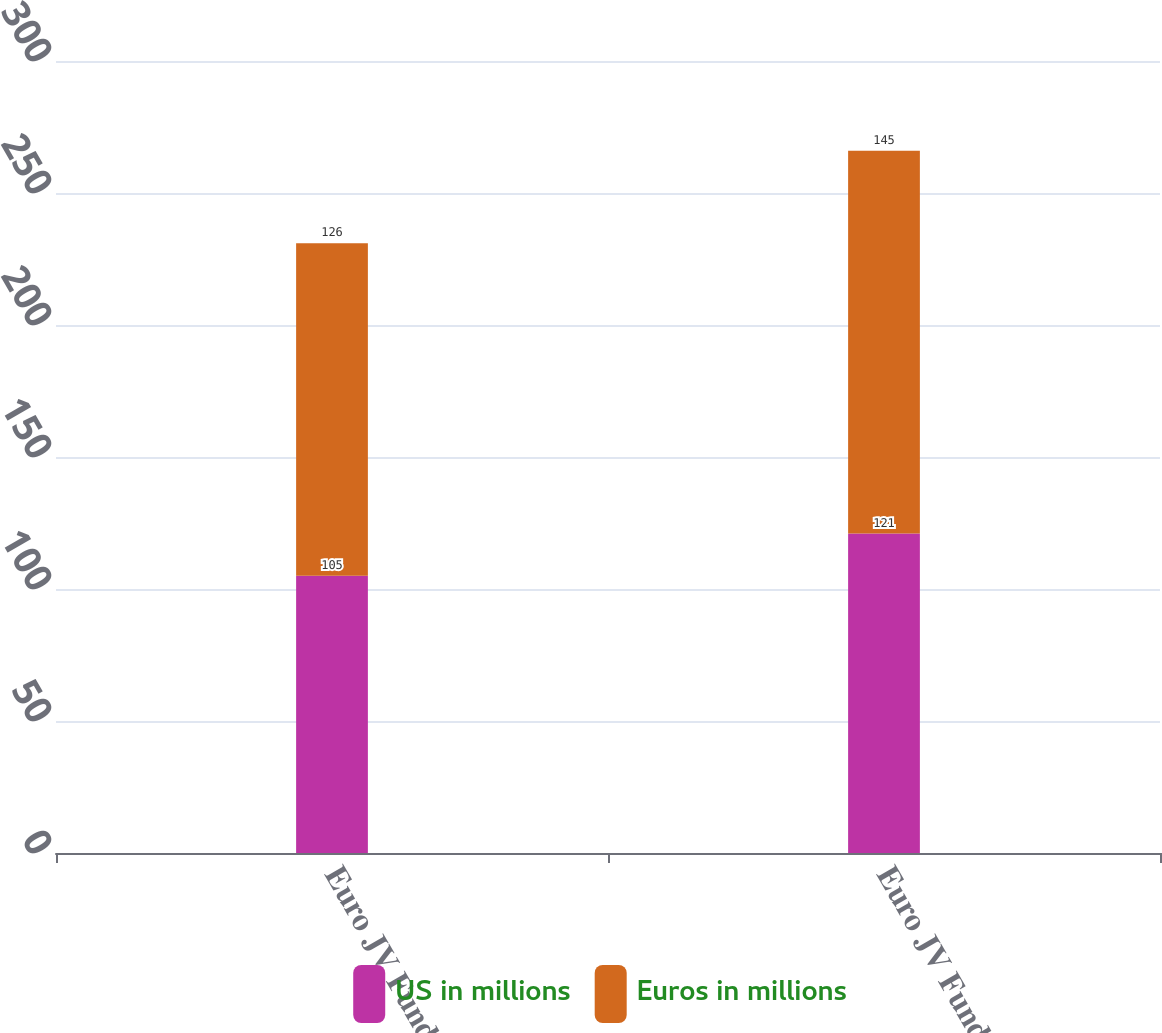Convert chart. <chart><loc_0><loc_0><loc_500><loc_500><stacked_bar_chart><ecel><fcel>Euro JV Fund I<fcel>Euro JV Fund II<nl><fcel>US in millions<fcel>105<fcel>121<nl><fcel>Euros in millions<fcel>126<fcel>145<nl></chart> 